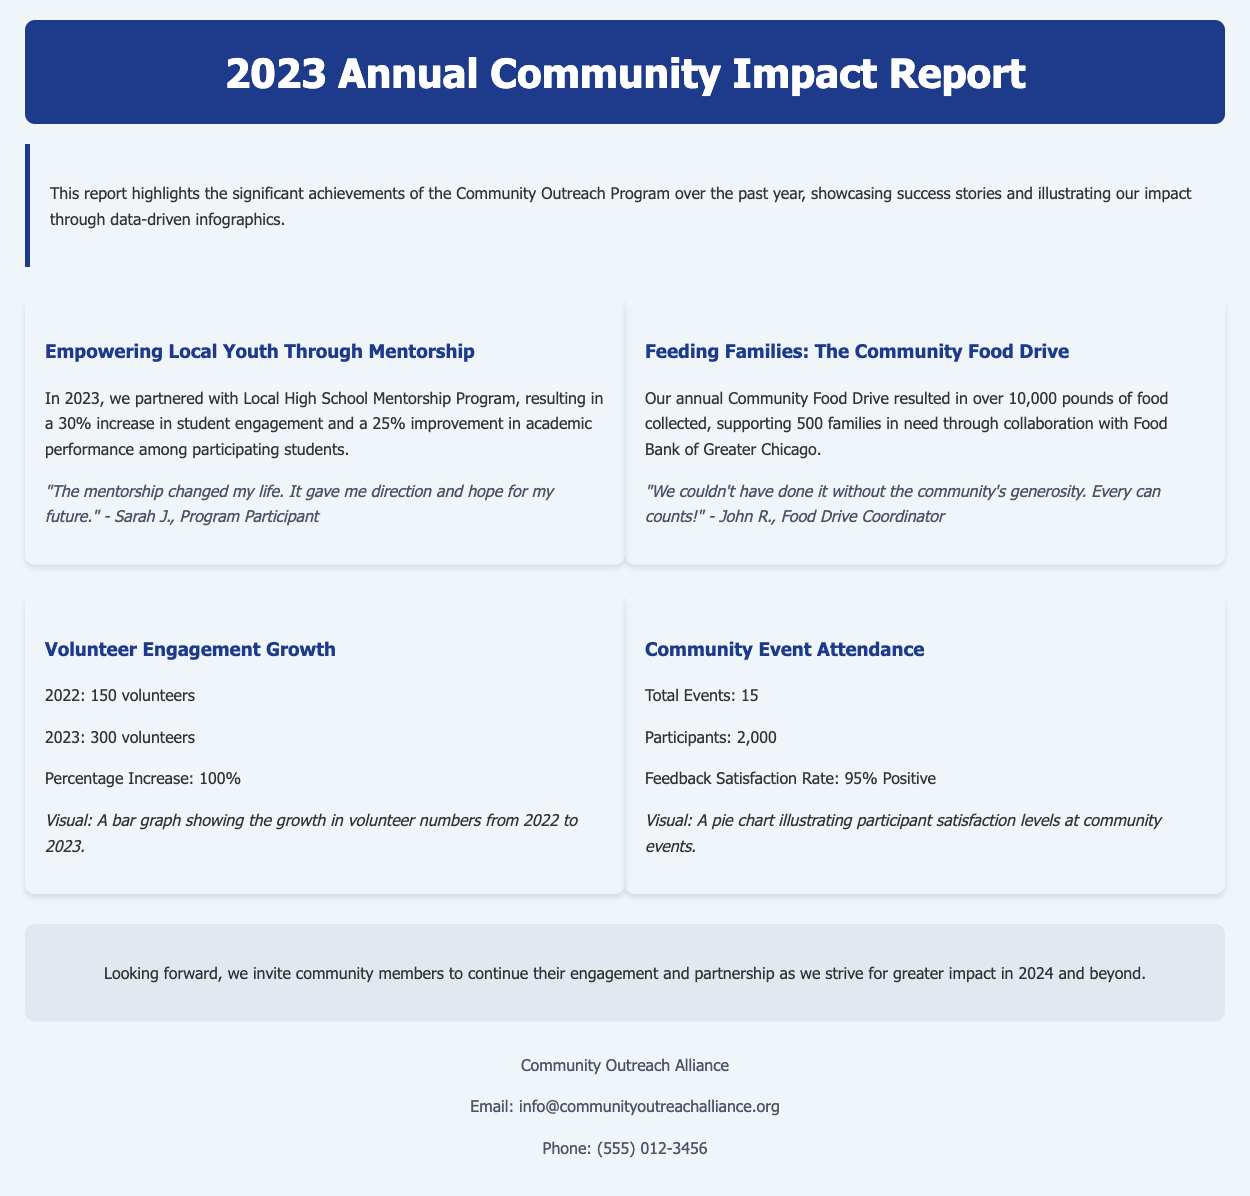What is the title of the report? The title is specified in the header section of the document.
Answer: 2023 Annual Community Impact Report What was the percentage increase in student engagement through the Mentorship Program? This information is found in the success story about the mentorship program.
Answer: 30% How many pounds of food were collected in the Community Food Drive? This figure is included in the success story regarding the food drive.
Answer: 10,000 pounds What is the feedback satisfaction rate for community event participants? This rate is included in the infographic section under Community Event Attendance.
Answer: 95% Positive How many volunteers were there in 2022? The number of volunteers in 2022 is presented in the infographic about volunteer engagement growth.
Answer: 150 What was the total number of community events held? This number is found in the infographic titled Community Event Attendance.
Answer: 15 What year did the Community Outreach Program feature significant achievements? The year is mentioned in the introduction of the report.
Answer: 2023 What is the name of the organization mentioned in the footer? This information is provided at the very end of the document.
Answer: Community Outreach Alliance 